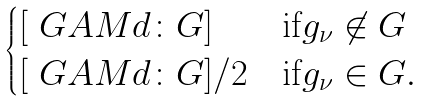Convert formula to latex. <formula><loc_0><loc_0><loc_500><loc_500>\begin{cases} [ \ G A M d \colon G ] & \text {if} g _ { \nu } \not \in G \\ [ \ G A M d \colon G ] / 2 & \text {if} g _ { \nu } \in G . \end{cases}</formula> 